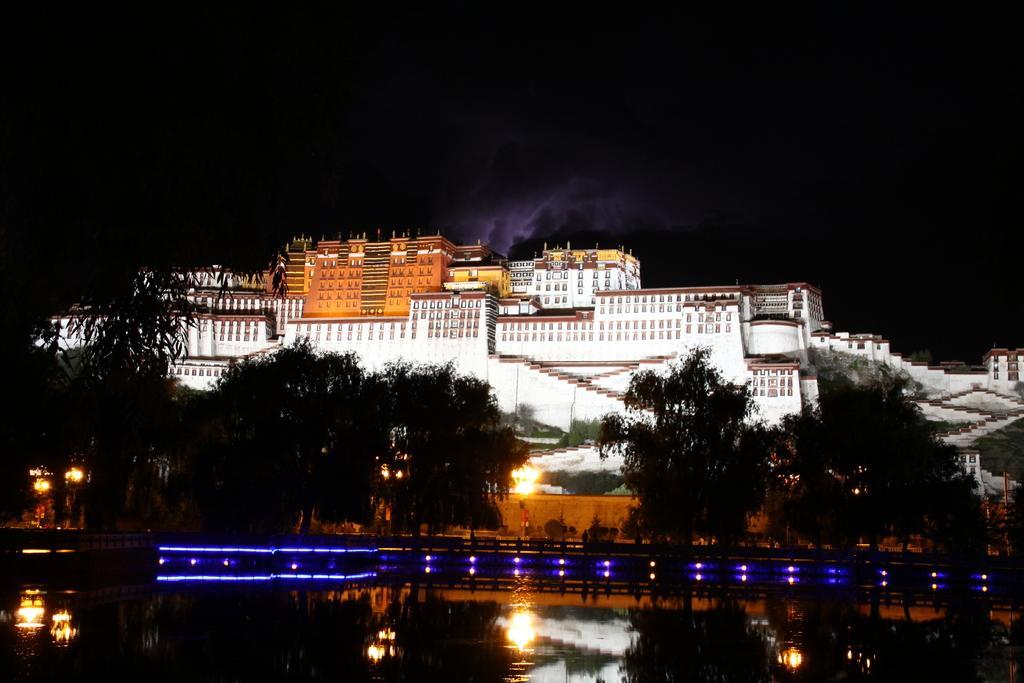Describe this image in one or two sentences. In this image we can see a group of buildings, trees, a water body, a fence, lights, a water body and the sky. 